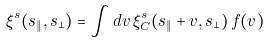<formula> <loc_0><loc_0><loc_500><loc_500>\xi ^ { s } ( s _ { \| } , s _ { \bot } ) = \int d v \, \xi ^ { s } _ { C } ( s _ { \| } + v , s _ { \bot } ) \, f ( v ) \,</formula> 